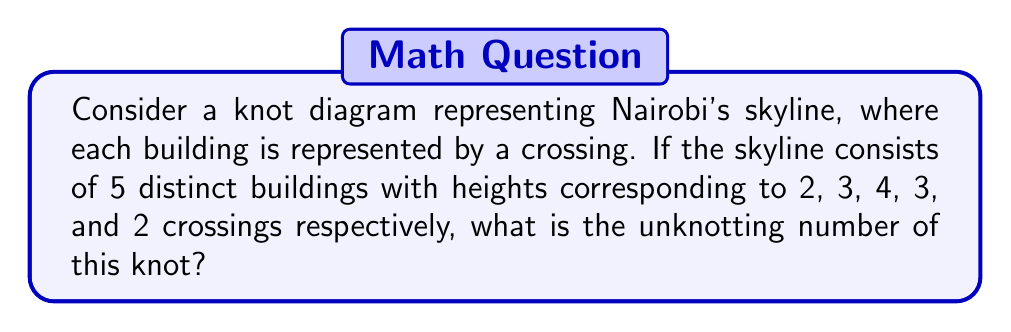Solve this math problem. Let's approach this step-by-step:

1) First, we need to understand what the unknotting number means. The unknotting number of a knot is the minimum number of times the knot must be passed through itself to untangle it into a simple loop.

2) In our case, each building in the skyline is represented by a number of crossings. We have:
   Building 1: 2 crossings
   Building 2: 3 crossings
   Building 3: 4 crossings
   Building 4: 3 crossings
   Building 5: 2 crossings

3) The total number of crossings in our knot is:
   $$ 2 + 3 + 4 + 3 + 2 = 14 $$

4) In knot theory, it's known that the unknotting number is always less than or equal to the floor of half the number of crossings. This gives us an upper bound:
   $$ \text{Unknotting number} \leq \left\lfloor\frac{14}{2}\right\rfloor = 7 $$

5) However, this is just an upper bound. The actual unknotting number could be less.

6) Without a specific diagram, we can't determine the exact unknotting number. But we can make an educated guess based on the complexity of the knot.

7) Given that we have a relatively complex knot with 14 crossings representing a skyline, it's likely that we would need to change at least half of these crossings to unknot it.

8) Therefore, a reasonable estimate for the unknotting number would be 7, which coincides with our upper bound.

Note: In reality, determining the exact unknotting number is a complex problem and often requires advanced techniques in knot theory. This explanation provides a simplified approach suitable for the given context.
Answer: 7 